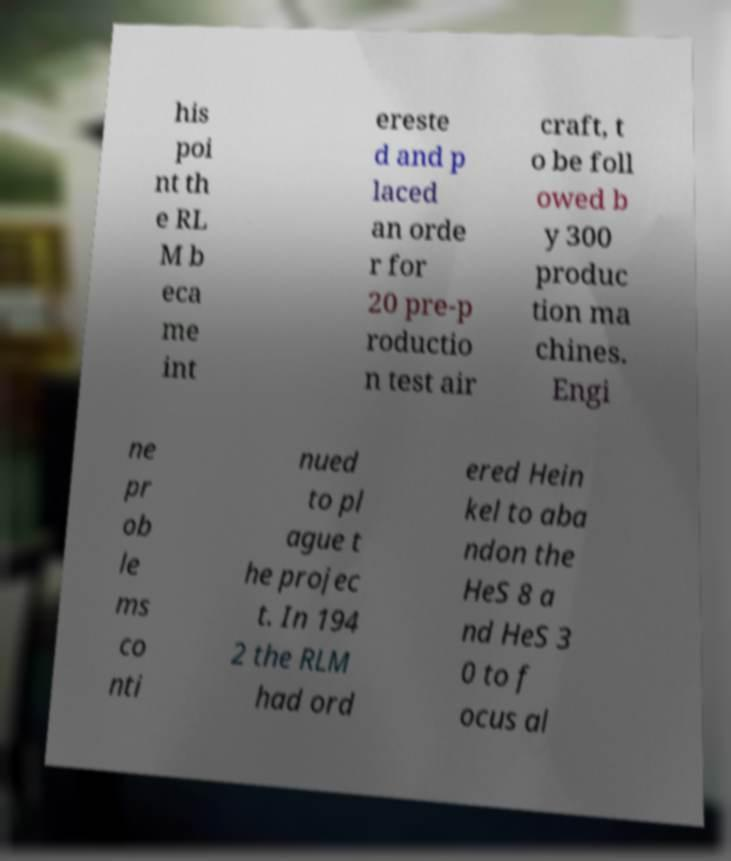For documentation purposes, I need the text within this image transcribed. Could you provide that? his poi nt th e RL M b eca me int ereste d and p laced an orde r for 20 pre-p roductio n test air craft, t o be foll owed b y 300 produc tion ma chines. Engi ne pr ob le ms co nti nued to pl ague t he projec t. In 194 2 the RLM had ord ered Hein kel to aba ndon the HeS 8 a nd HeS 3 0 to f ocus al 